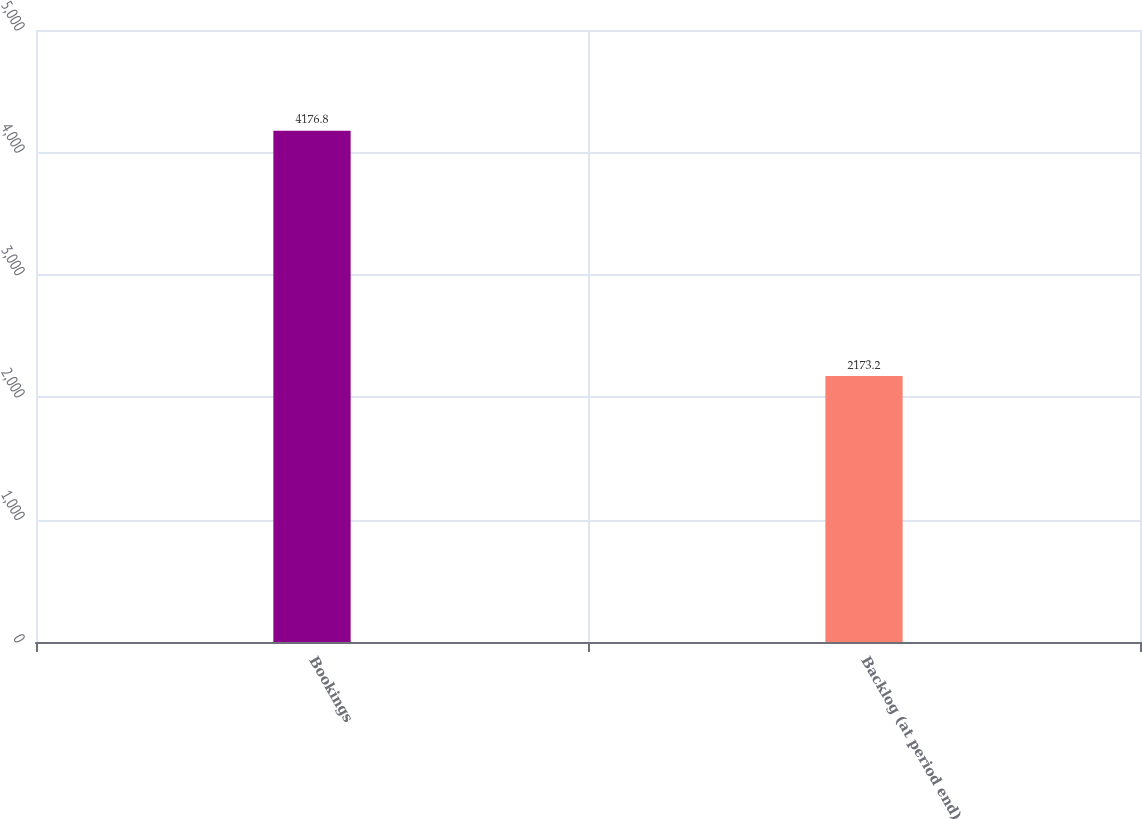Convert chart to OTSL. <chart><loc_0><loc_0><loc_500><loc_500><bar_chart><fcel>Bookings<fcel>Backlog (at period end)<nl><fcel>4176.8<fcel>2173.2<nl></chart> 